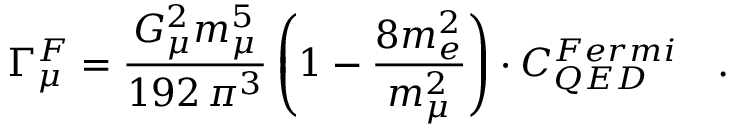Convert formula to latex. <formula><loc_0><loc_0><loc_500><loc_500>\Gamma _ { \mu } ^ { F } = \frac { G _ { \mu } ^ { 2 } m _ { \mu } ^ { 5 } } { 1 9 2 \, \pi ^ { 3 } } \left ( 1 - \frac { 8 m _ { e } ^ { 2 } } { m _ { \mu } ^ { 2 } } \right ) \cdot C _ { Q E D } ^ { F e r m i } \quad .</formula> 